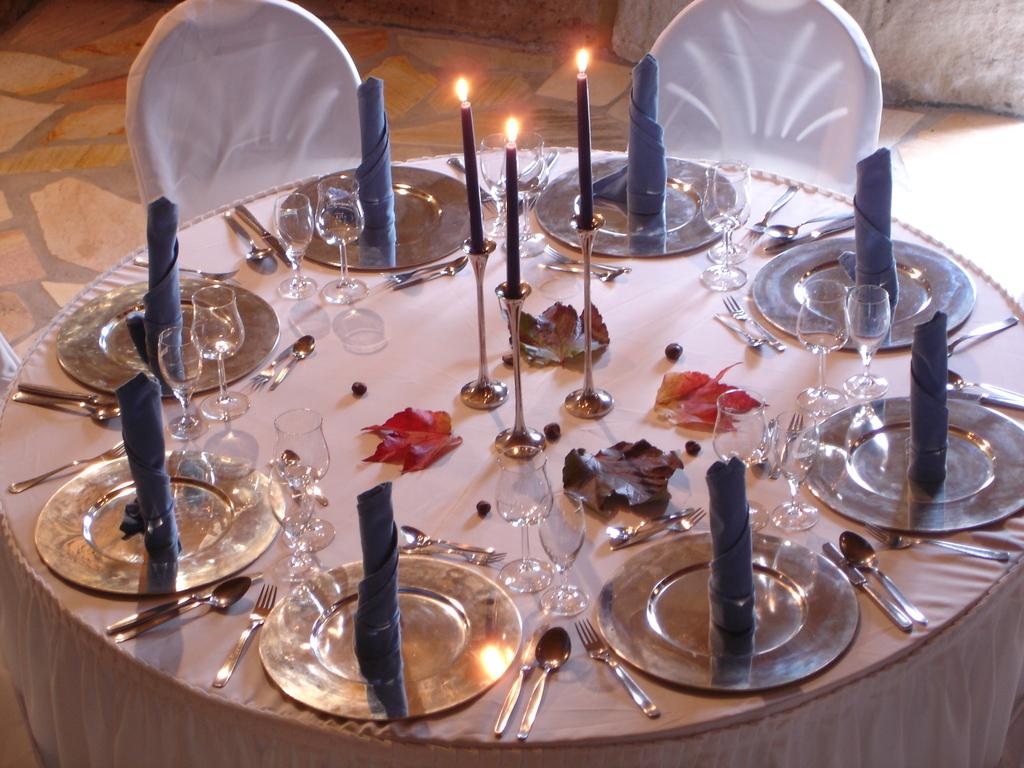What is the main piece of furniture in the image? There is a table in the image. What is covering the table? There is a cloth on the table. What type of glassware is present on the table? There are wine glasses on the table. What is the source of light on the table? There is a candle on the table. What type of plant material is on the table? There is a leaf on the table. What is used for serving food on the table? There is a plate on the table. What utensils are present on the table? There are spoons and forks on the table. What is used for cleaning or wiping on the table? There are napkins on the table. What can be seen in the background of the image? There is a wall and chairs in the background of the image. Where is the meeting taking place in the image? There is no meeting taking place in the image; it is a still image of a table setting. How many frogs can be seen on the table in the image? There are no frogs present in the image. 